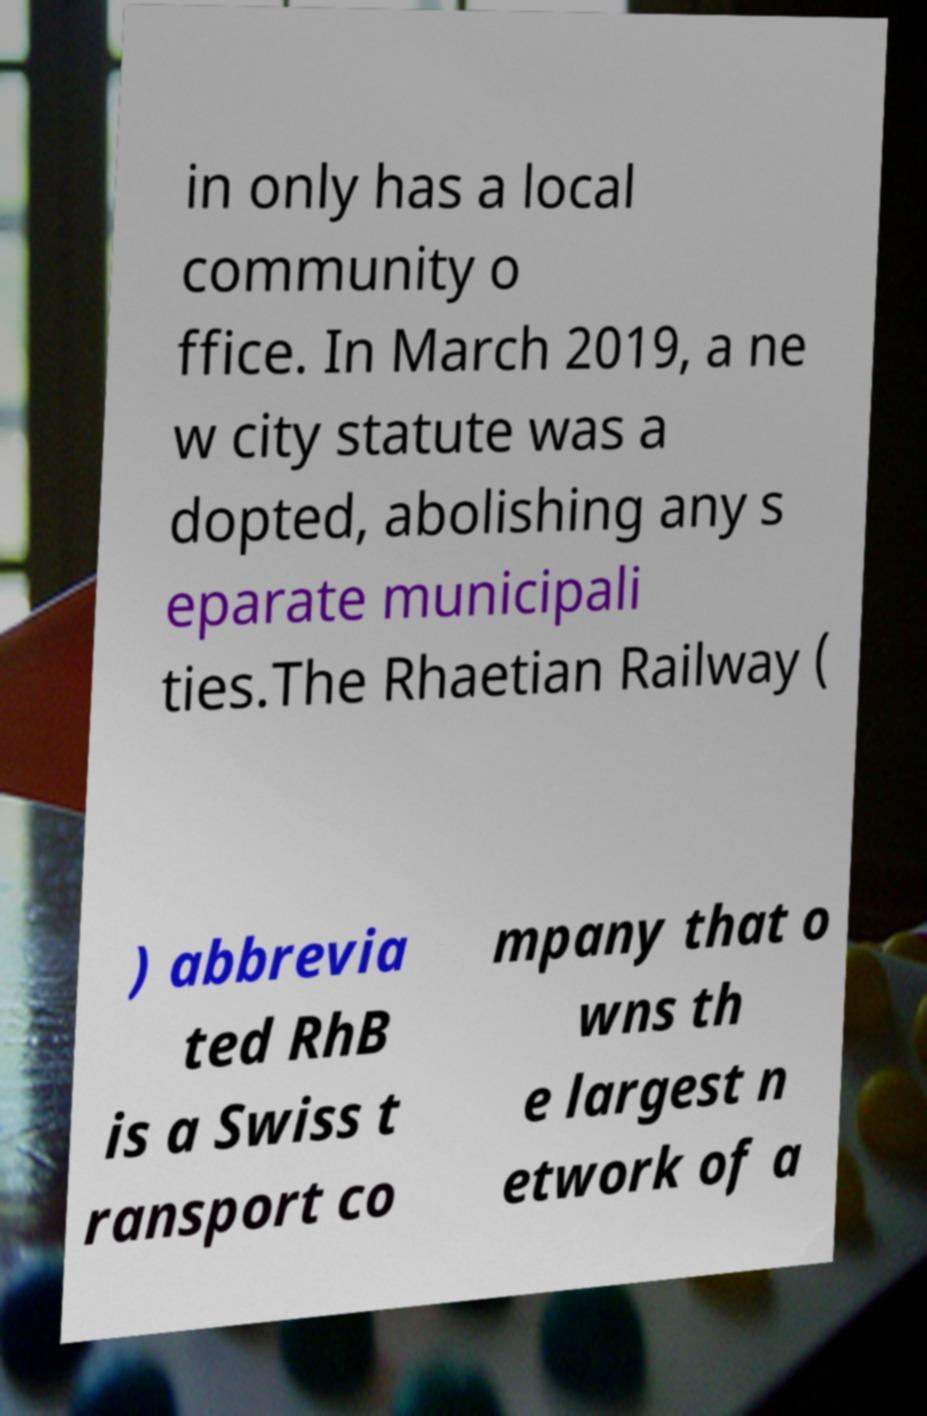Please identify and transcribe the text found in this image. in only has a local community o ffice. In March 2019, a ne w city statute was a dopted, abolishing any s eparate municipali ties.The Rhaetian Railway ( ) abbrevia ted RhB is a Swiss t ransport co mpany that o wns th e largest n etwork of a 